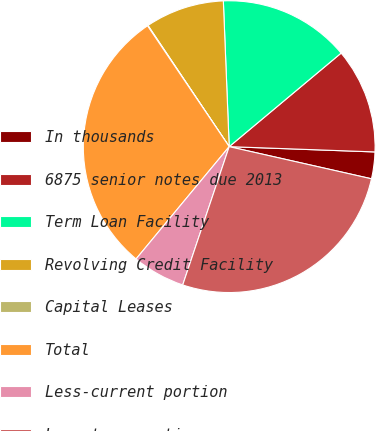<chart> <loc_0><loc_0><loc_500><loc_500><pie_chart><fcel>In thousands<fcel>6875 senior notes due 2013<fcel>Term Loan Facility<fcel>Revolving Credit Facility<fcel>Capital Leases<fcel>Total<fcel>Less-current portion<fcel>Long-term portion<nl><fcel>2.96%<fcel>11.66%<fcel>14.56%<fcel>8.76%<fcel>0.06%<fcel>29.53%<fcel>5.86%<fcel>26.63%<nl></chart> 